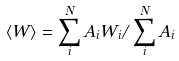Convert formula to latex. <formula><loc_0><loc_0><loc_500><loc_500>\langle W \rangle = \sum _ { i } ^ { N } A _ { i } W _ { i } / \sum _ { i } ^ { N } A _ { i }</formula> 